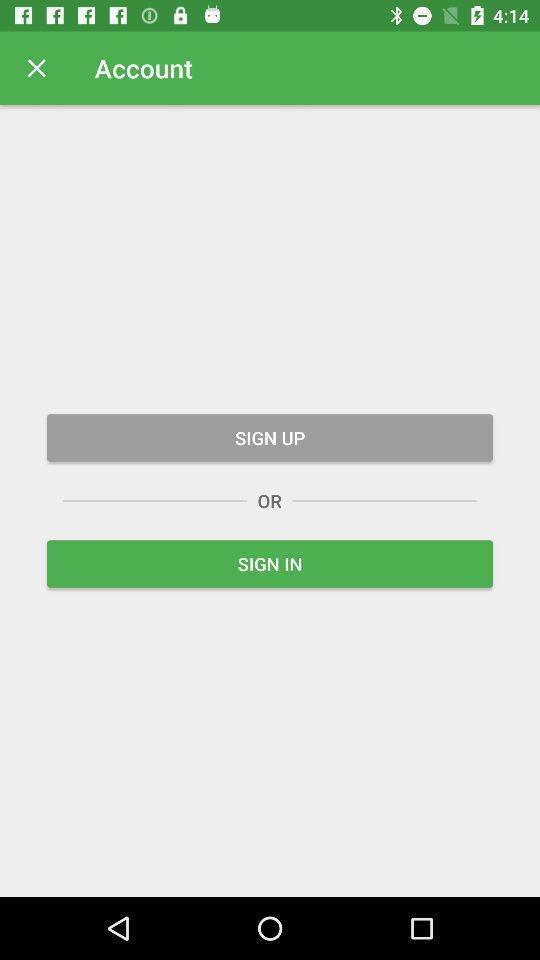What is the overall content of this screenshot? Sign up/sign in page. 